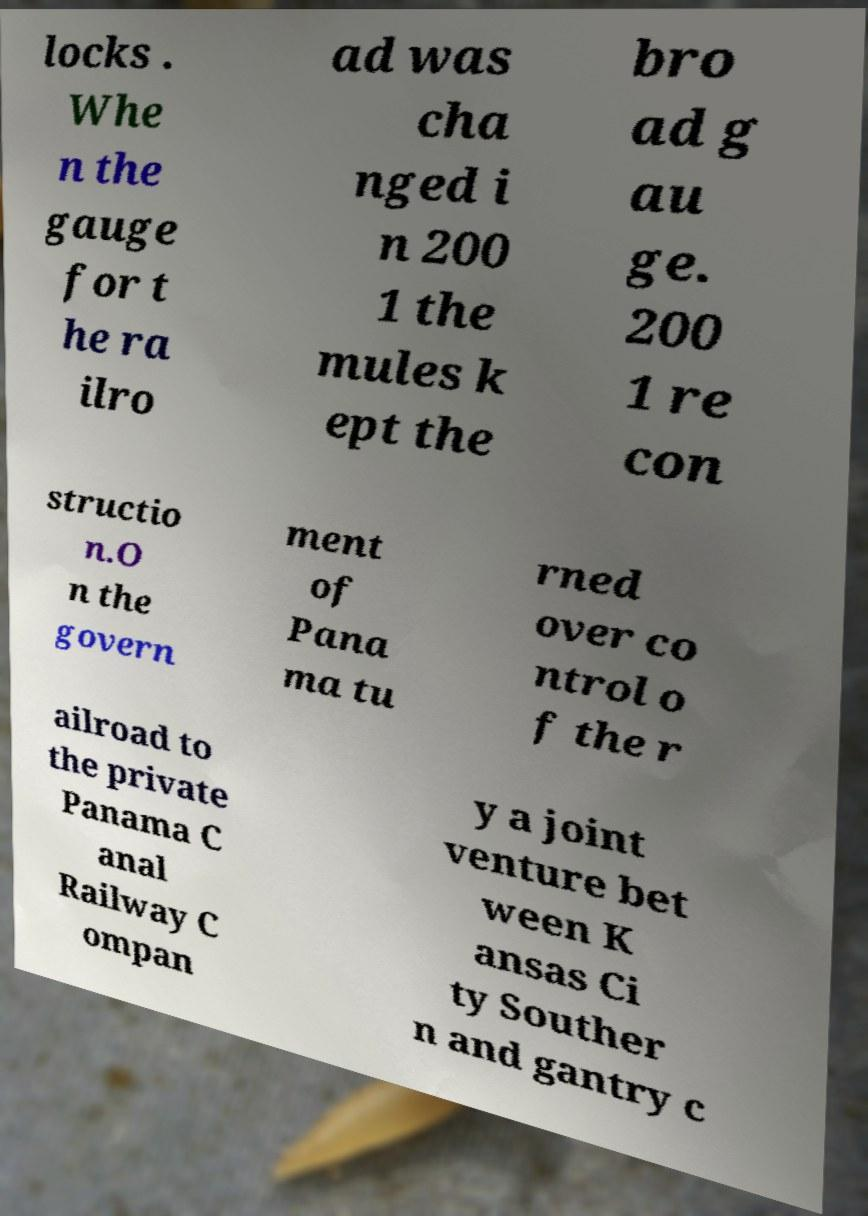Could you assist in decoding the text presented in this image and type it out clearly? locks . Whe n the gauge for t he ra ilro ad was cha nged i n 200 1 the mules k ept the bro ad g au ge. 200 1 re con structio n.O n the govern ment of Pana ma tu rned over co ntrol o f the r ailroad to the private Panama C anal Railway C ompan y a joint venture bet ween K ansas Ci ty Souther n and gantry c 